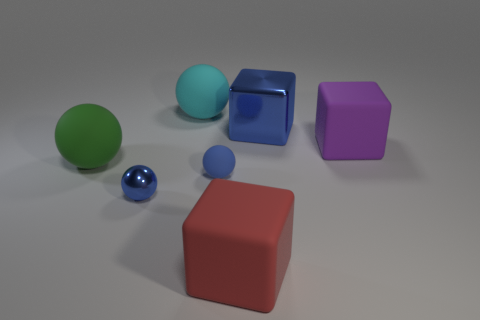What material is the blue thing right of the big rubber block that is to the left of the large object on the right side of the blue metal block?
Give a very brief answer. Metal. Is there a big ball that has the same color as the metal cube?
Provide a short and direct response. No. Are there fewer small blue objects that are behind the small rubber thing than large blue objects?
Make the answer very short. Yes. Does the blue thing on the right side of the red thing have the same size as the big green matte object?
Offer a terse response. Yes. How many objects are both right of the green ball and behind the metal sphere?
Your answer should be compact. 4. There is a blue metallic thing to the left of the blue object to the right of the big red thing; what is its size?
Provide a succinct answer. Small. Is the number of green matte objects behind the large cyan matte thing less than the number of blue metal objects behind the green rubber sphere?
Keep it short and to the point. Yes. There is a small thing that is in front of the blue rubber object; does it have the same color as the large rubber object that is to the right of the large red object?
Your answer should be compact. No. The blue object that is both in front of the green rubber sphere and right of the blue metal sphere is made of what material?
Make the answer very short. Rubber. Is there a tiny red matte ball?
Offer a very short reply. No. 